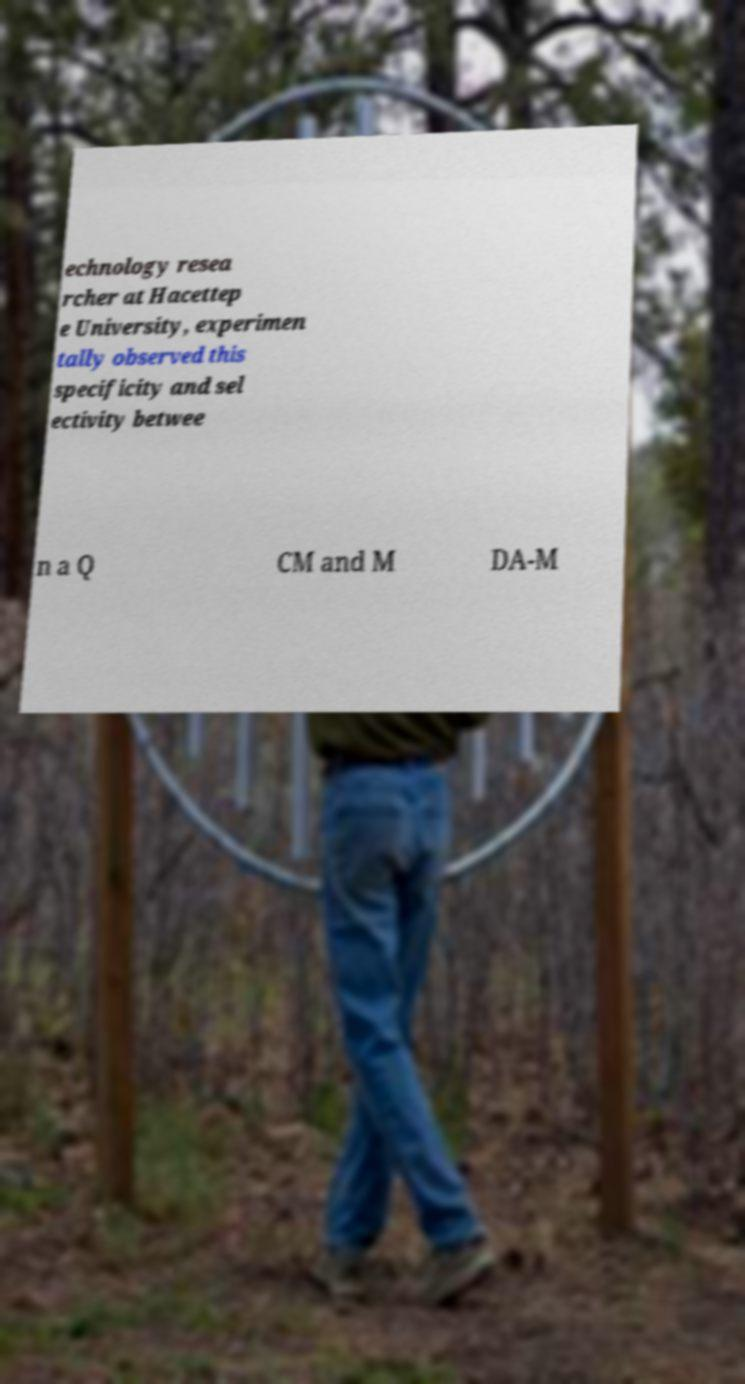Please identify and transcribe the text found in this image. echnology resea rcher at Hacettep e University, experimen tally observed this specificity and sel ectivity betwee n a Q CM and M DA-M 